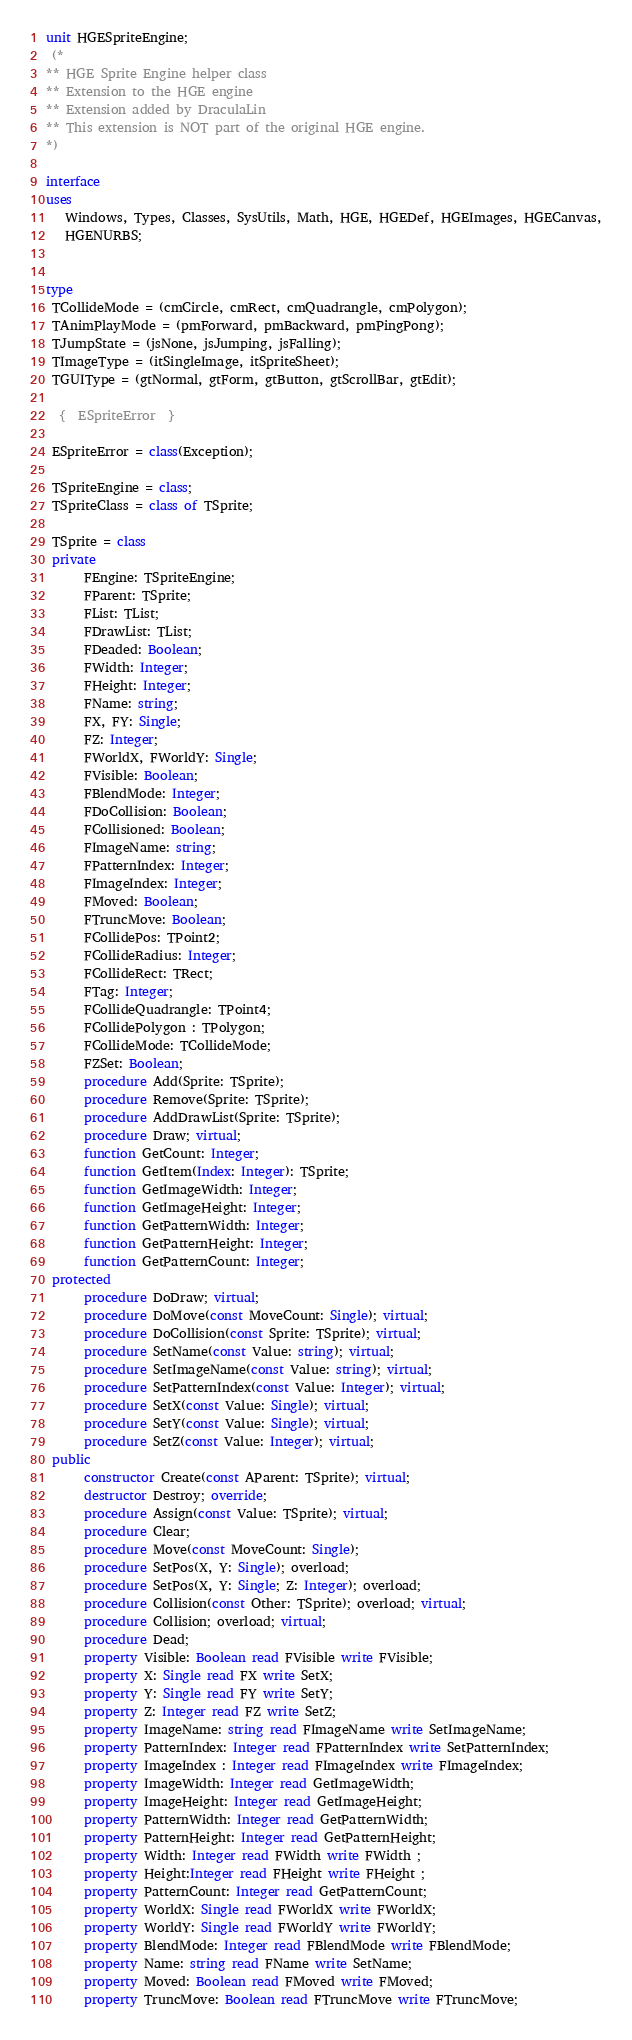<code> <loc_0><loc_0><loc_500><loc_500><_Pascal_>unit HGESpriteEngine;
 (*
** HGE Sprite Engine helper class
** Extension to the HGE engine
** Extension added by DraculaLin
** This extension is NOT part of the original HGE engine.
*)

interface
uses
   Windows, Types, Classes, SysUtils, Math, HGE, HGEDef, HGEImages, HGECanvas,
   HGENURBS;


type
 TCollideMode = (cmCircle, cmRect, cmQuadrangle, cmPolygon);
 TAnimPlayMode = (pmForward, pmBackward, pmPingPong);
 TJumpState = (jsNone, jsJumping, jsFalling);
 TImageType = (itSingleImage, itSpriteSheet);
 TGUIType = (gtNormal, gtForm, gtButton, gtScrollBar, gtEdit);

  {  ESpriteError  }

 ESpriteError = class(Exception);

 TSpriteEngine = class;
 TSpriteClass = class of TSprite;

 TSprite = class
 private
      FEngine: TSpriteEngine;
      FParent: TSprite;
      FList: TList;
      FDrawList: TList;
      FDeaded: Boolean;
      FWidth: Integer;
      FHeight: Integer;
      FName: string;
      FX, FY: Single;
      FZ: Integer;
      FWorldX, FWorldY: Single;
      FVisible: Boolean;
      FBlendMode: Integer;
      FDoCollision: Boolean;
      FCollisioned: Boolean;
      FImageName: string;
      FPatternIndex: Integer;
      FImageIndex: Integer;
      FMoved: Boolean;
      FTruncMove: Boolean;
      FCollidePos: TPoint2;
      FCollideRadius: Integer;
      FCollideRect: TRect;
      FTag: Integer;
      FCollideQuadrangle: TPoint4;
      FCollidePolygon : TPolygon;
      FCollideMode: TCollideMode;
      FZSet: Boolean;
      procedure Add(Sprite: TSprite);
      procedure Remove(Sprite: TSprite);
      procedure AddDrawList(Sprite: TSprite);
      procedure Draw; virtual;
      function GetCount: Integer;
      function GetItem(Index: Integer): TSprite;
      function GetImageWidth: Integer;
      function GetImageHeight: Integer;
      function GetPatternWidth: Integer;
      function GetPatternHeight: Integer;
      function GetPatternCount: Integer;
 protected
      procedure DoDraw; virtual;
      procedure DoMove(const MoveCount: Single); virtual;
      procedure DoCollision(const Sprite: TSprite); virtual;
      procedure SetName(const Value: string); virtual;
      procedure SetImageName(const Value: string); virtual;
      procedure SetPatternIndex(const Value: Integer); virtual;
      procedure SetX(const Value: Single); virtual;
      procedure SetY(const Value: Single); virtual;
      procedure SetZ(const Value: Integer); virtual;
 public
      constructor Create(const AParent: TSprite); virtual;
      destructor Destroy; override;
      procedure Assign(const Value: TSprite); virtual;
      procedure Clear;
      procedure Move(const MoveCount: Single);
      procedure SetPos(X, Y: Single); overload;
      procedure SetPos(X, Y: Single; Z: Integer); overload;
      procedure Collision(const Other: TSprite); overload; virtual;
      procedure Collision; overload; virtual;
      procedure Dead;
      property Visible: Boolean read FVisible write FVisible;
      property X: Single read FX write SetX;
      property Y: Single read FY write SetY;
      property Z: Integer read FZ write SetZ;
      property ImageName: string read FImageName write SetImageName;
      property PatternIndex: Integer read FPatternIndex write SetPatternIndex;
      property ImageIndex : Integer read FImageIndex write FImageIndex;
      property ImageWidth: Integer read GetImageWidth;
      property ImageHeight: Integer read GetImageHeight;
      property PatternWidth: Integer read GetPatternWidth;
      property PatternHeight: Integer read GetPatternHeight;
      property Width: Integer read FWidth write FWidth ;
      property Height:Integer read FHeight write FHeight ;
      property PatternCount: Integer read GetPatternCount;
      property WorldX: Single read FWorldX write FWorldX;
      property WorldY: Single read FWorldY write FWorldY;
      property BlendMode: Integer read FBlendMode write FBlendMode;
      property Name: string read FName write SetName;
      property Moved: Boolean read FMoved write FMoved;
      property TruncMove: Boolean read FTruncMove write FTruncMove;</code> 